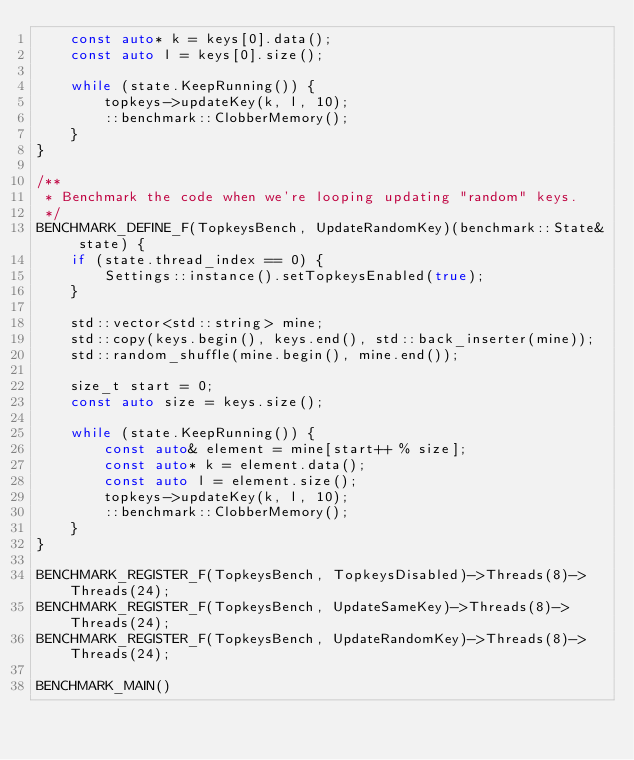<code> <loc_0><loc_0><loc_500><loc_500><_C++_>    const auto* k = keys[0].data();
    const auto l = keys[0].size();

    while (state.KeepRunning()) {
        topkeys->updateKey(k, l, 10);
        ::benchmark::ClobberMemory();
    }
}

/**
 * Benchmark the code when we're looping updating "random" keys.
 */
BENCHMARK_DEFINE_F(TopkeysBench, UpdateRandomKey)(benchmark::State& state) {
    if (state.thread_index == 0) {
        Settings::instance().setTopkeysEnabled(true);
    }

    std::vector<std::string> mine;
    std::copy(keys.begin(), keys.end(), std::back_inserter(mine));
    std::random_shuffle(mine.begin(), mine.end());

    size_t start = 0;
    const auto size = keys.size();

    while (state.KeepRunning()) {
        const auto& element = mine[start++ % size];
        const auto* k = element.data();
        const auto l = element.size();
        topkeys->updateKey(k, l, 10);
        ::benchmark::ClobberMemory();
    }
}

BENCHMARK_REGISTER_F(TopkeysBench, TopkeysDisabled)->Threads(8)->Threads(24);
BENCHMARK_REGISTER_F(TopkeysBench, UpdateSameKey)->Threads(8)->Threads(24);
BENCHMARK_REGISTER_F(TopkeysBench, UpdateRandomKey)->Threads(8)->Threads(24);

BENCHMARK_MAIN()
</code> 